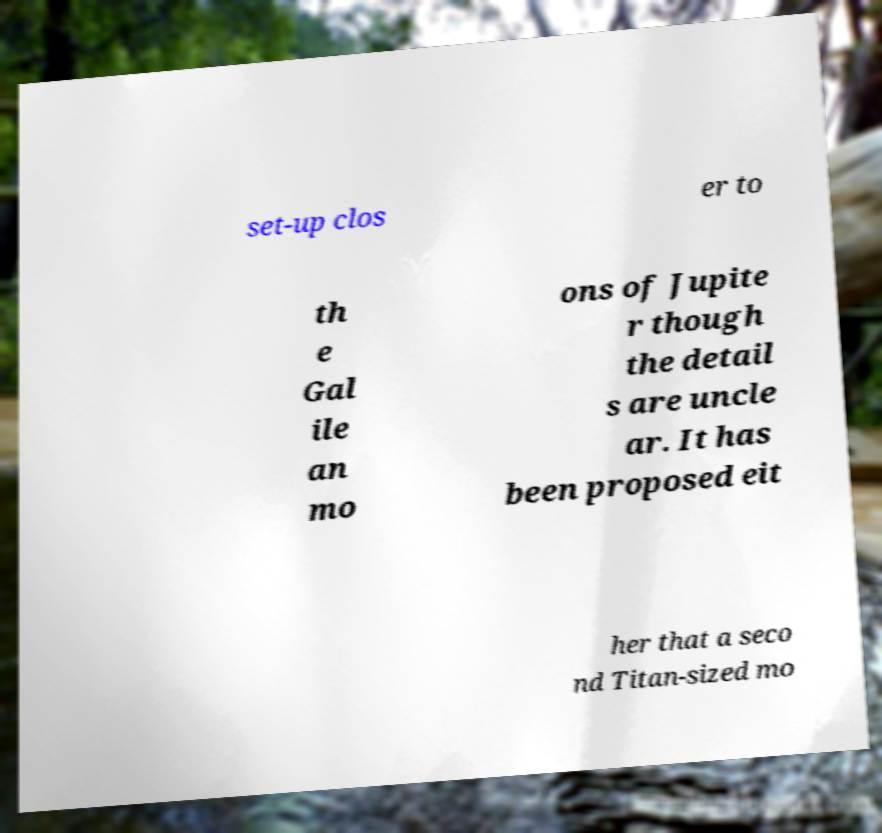Please identify and transcribe the text found in this image. set-up clos er to th e Gal ile an mo ons of Jupite r though the detail s are uncle ar. It has been proposed eit her that a seco nd Titan-sized mo 